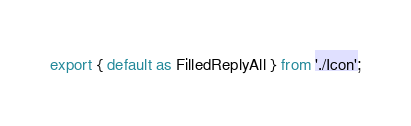Convert code to text. <code><loc_0><loc_0><loc_500><loc_500><_TypeScript_>export { default as FilledReplyAll } from './Icon';
</code> 